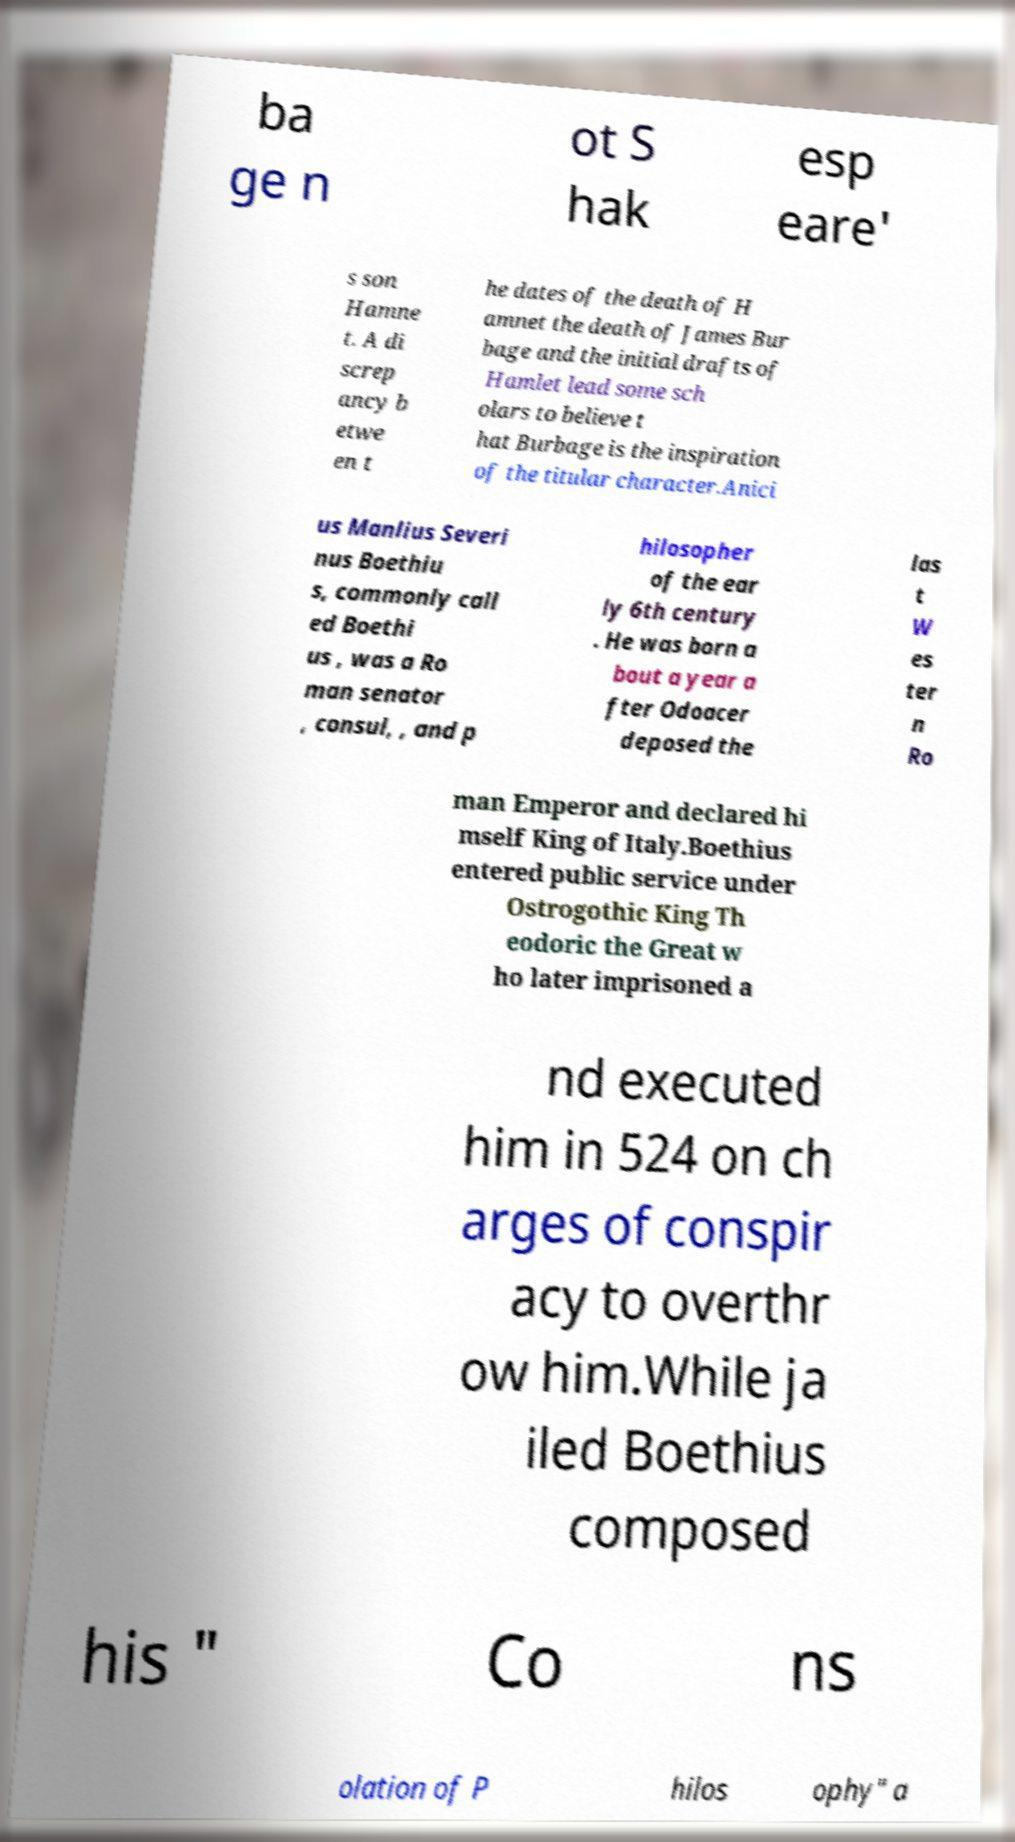There's text embedded in this image that I need extracted. Can you transcribe it verbatim? ba ge n ot S hak esp eare' s son Hamne t. A di screp ancy b etwe en t he dates of the death of H amnet the death of James Bur bage and the initial drafts of Hamlet lead some sch olars to believe t hat Burbage is the inspiration of the titular character.Anici us Manlius Severi nus Boethiu s, commonly call ed Boethi us , was a Ro man senator , consul, , and p hilosopher of the ear ly 6th century . He was born a bout a year a fter Odoacer deposed the las t W es ter n Ro man Emperor and declared hi mself King of Italy.Boethius entered public service under Ostrogothic King Th eodoric the Great w ho later imprisoned a nd executed him in 524 on ch arges of conspir acy to overthr ow him.While ja iled Boethius composed his " Co ns olation of P hilos ophy" a 